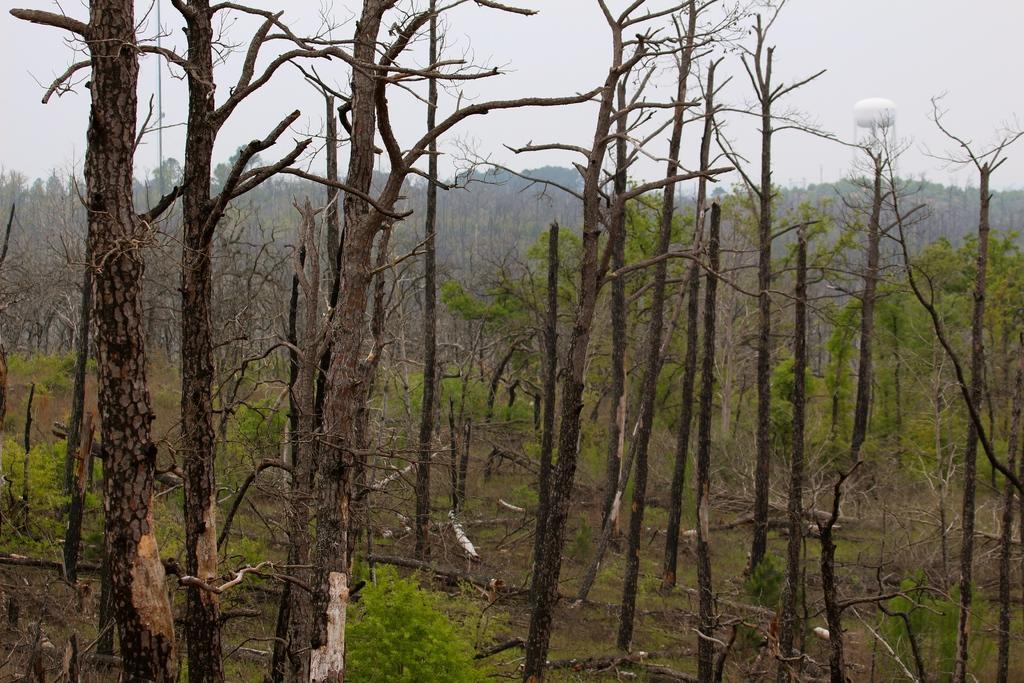In one or two sentences, can you explain what this image depicts? In this picture we can see few trees and wooden trunks, in the background we can see a tower. 